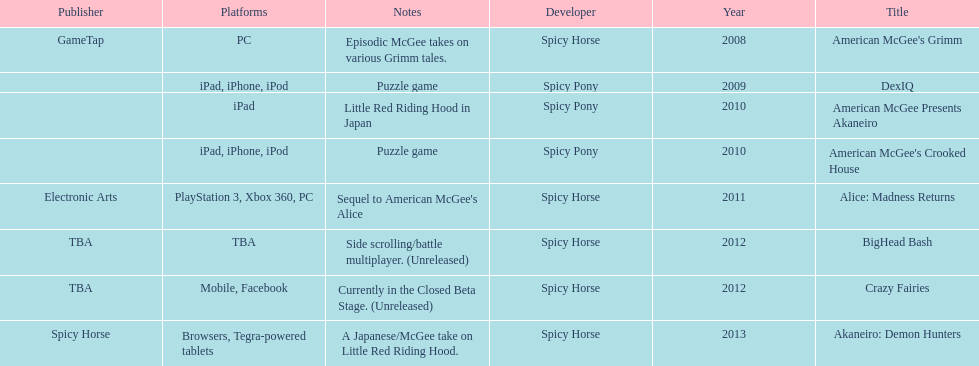What year had a total of 2 titles released? 2010. 